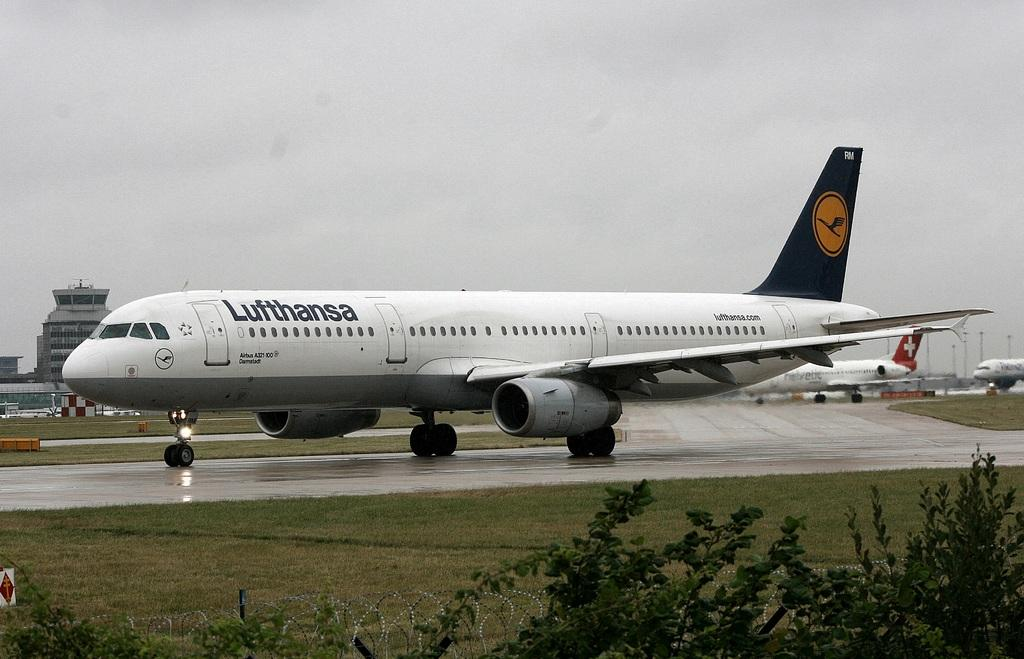<image>
Share a concise interpretation of the image provided. The white plane on the runway is from Lufthansa. 